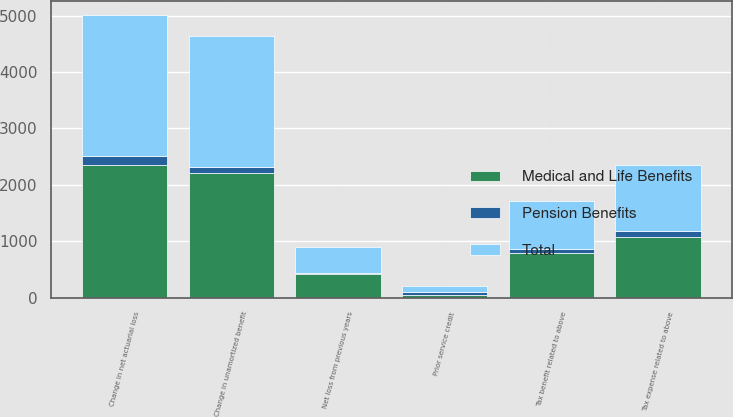Convert chart. <chart><loc_0><loc_0><loc_500><loc_500><stacked_bar_chart><ecel><fcel>Change in net actuarial loss<fcel>Prior service credit<fcel>Net loss from previous years<fcel>Tax benefit related to above<fcel>Change in unamortized benefit<fcel>Tax expense related to above<nl><fcel>Medical and Life Benefits<fcel>2353<fcel>58<fcel>427<fcel>788<fcel>2208<fcel>1075<nl><fcel>Pension Benefits<fcel>151<fcel>51<fcel>21<fcel>72<fcel>108<fcel>102<nl><fcel>Total<fcel>2504<fcel>109<fcel>448<fcel>860<fcel>2316<fcel>1177<nl></chart> 